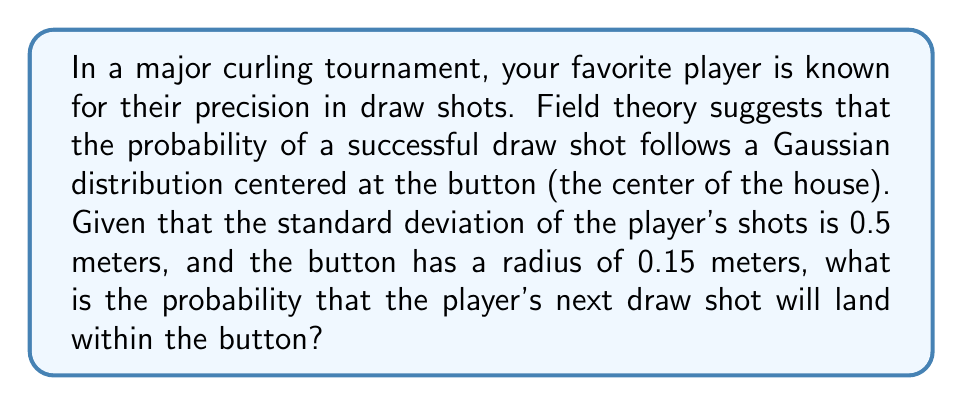Solve this math problem. Let's approach this step-by-step using field theory concepts:

1) The probability distribution of the shot landing at a certain point follows a 2D Gaussian distribution centered at the button. In polar coordinates, this can be expressed as:

   $$f(r) = \frac{1}{2\pi\sigma^2} e^{-\frac{r^2}{2\sigma^2}}$$

   where $r$ is the distance from the button and $\sigma$ is the standard deviation.

2) We're given that $\sigma = 0.5$ meters.

3) To find the probability of the shot landing within the button, we need to integrate this function over the area of the button. In polar coordinates, this is:

   $$P(\text{within button}) = \int_0^{2\pi} \int_0^{0.15} f(r) r dr d\theta$$

4) Substituting our function and simplifying:

   $$P(\text{within button}) = \int_0^{2\pi} \int_0^{0.15} \frac{1}{2\pi(0.5)^2} e^{-\frac{r^2}{2(0.5)^2}} r dr d\theta$$

5) The $\theta$ integral evaluates to $2\pi$, cancelling with the $2\pi$ in the denominator:

   $$P(\text{within button}) = \int_0^{0.15} \frac{1}{(0.5)^2} e^{-\frac{r^2}{2(0.5)^2}} r dr$$

6) This integrates to:

   $$P(\text{within button}) = 1 - e^{-\frac{(0.15)^2}{2(0.5)^2}}$$

7) Evaluating this expression:

   $$P(\text{within button}) = 1 - e^{-0.045} \approx 0.0440$$

8) Converting to a percentage:

   $$P(\text{within button}) \approx 4.40\%$$
Answer: 4.40% 